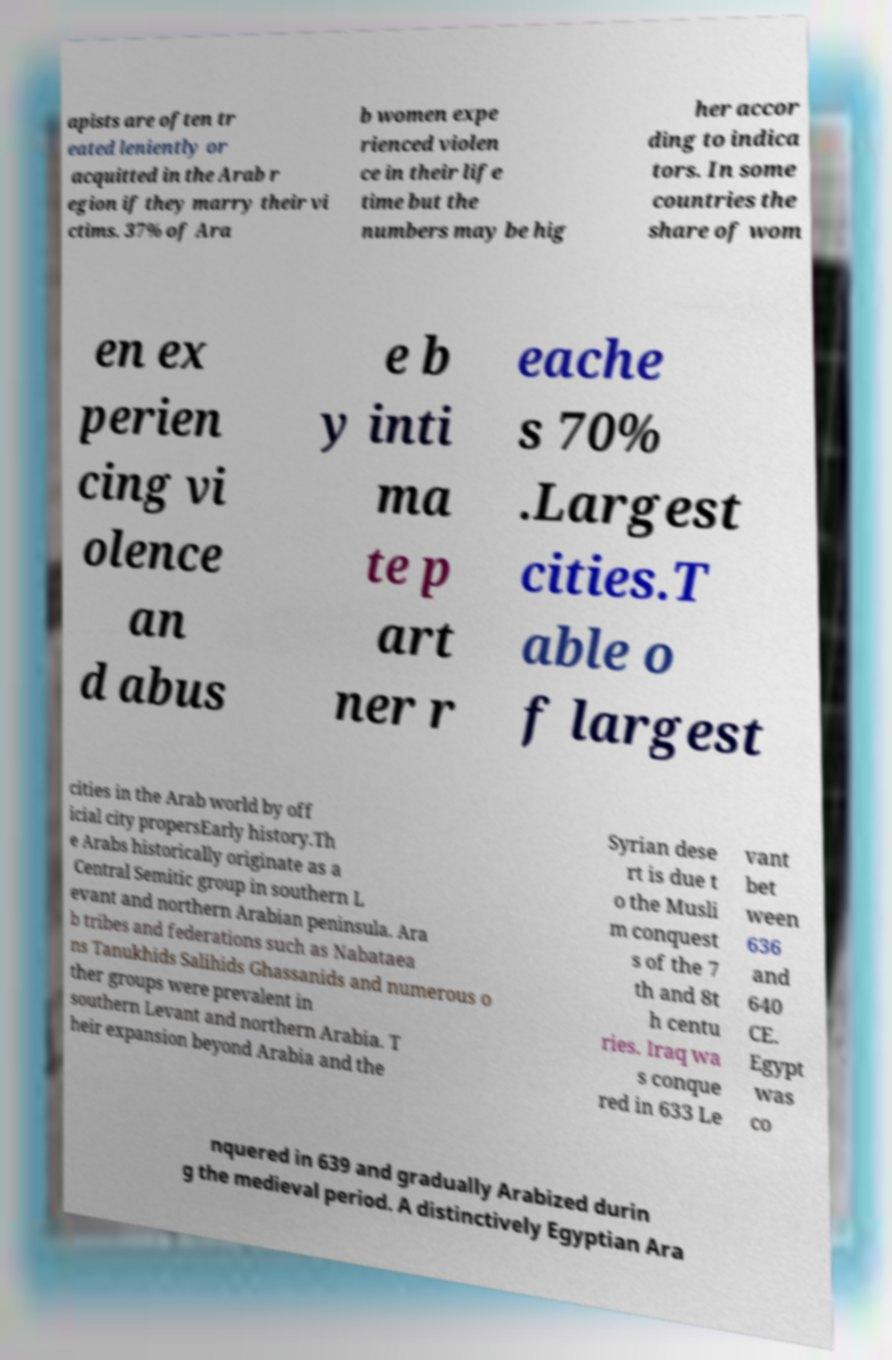Please read and relay the text visible in this image. What does it say? apists are often tr eated leniently or acquitted in the Arab r egion if they marry their vi ctims. 37% of Ara b women expe rienced violen ce in their life time but the numbers may be hig her accor ding to indica tors. In some countries the share of wom en ex perien cing vi olence an d abus e b y inti ma te p art ner r eache s 70% .Largest cities.T able o f largest cities in the Arab world by off icial city propersEarly history.Th e Arabs historically originate as a Central Semitic group in southern L evant and northern Arabian peninsula. Ara b tribes and federations such as Nabataea ns Tanukhids Salihids Ghassanids and numerous o ther groups were prevalent in southern Levant and northern Arabia. T heir expansion beyond Arabia and the Syrian dese rt is due t o the Musli m conquest s of the 7 th and 8t h centu ries. Iraq wa s conque red in 633 Le vant bet ween 636 and 640 CE. Egypt was co nquered in 639 and gradually Arabized durin g the medieval period. A distinctively Egyptian Ara 